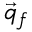<formula> <loc_0><loc_0><loc_500><loc_500>\vec { q } _ { f }</formula> 